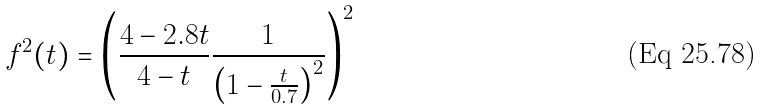<formula> <loc_0><loc_0><loc_500><loc_500>f ^ { 2 } ( t ) = \left ( \frac { 4 - 2 . 8 t } { 4 - t } \frac { 1 } { \left ( 1 - \frac { t } { 0 . 7 } \right ) ^ { 2 } } \right ) ^ { 2 }</formula> 